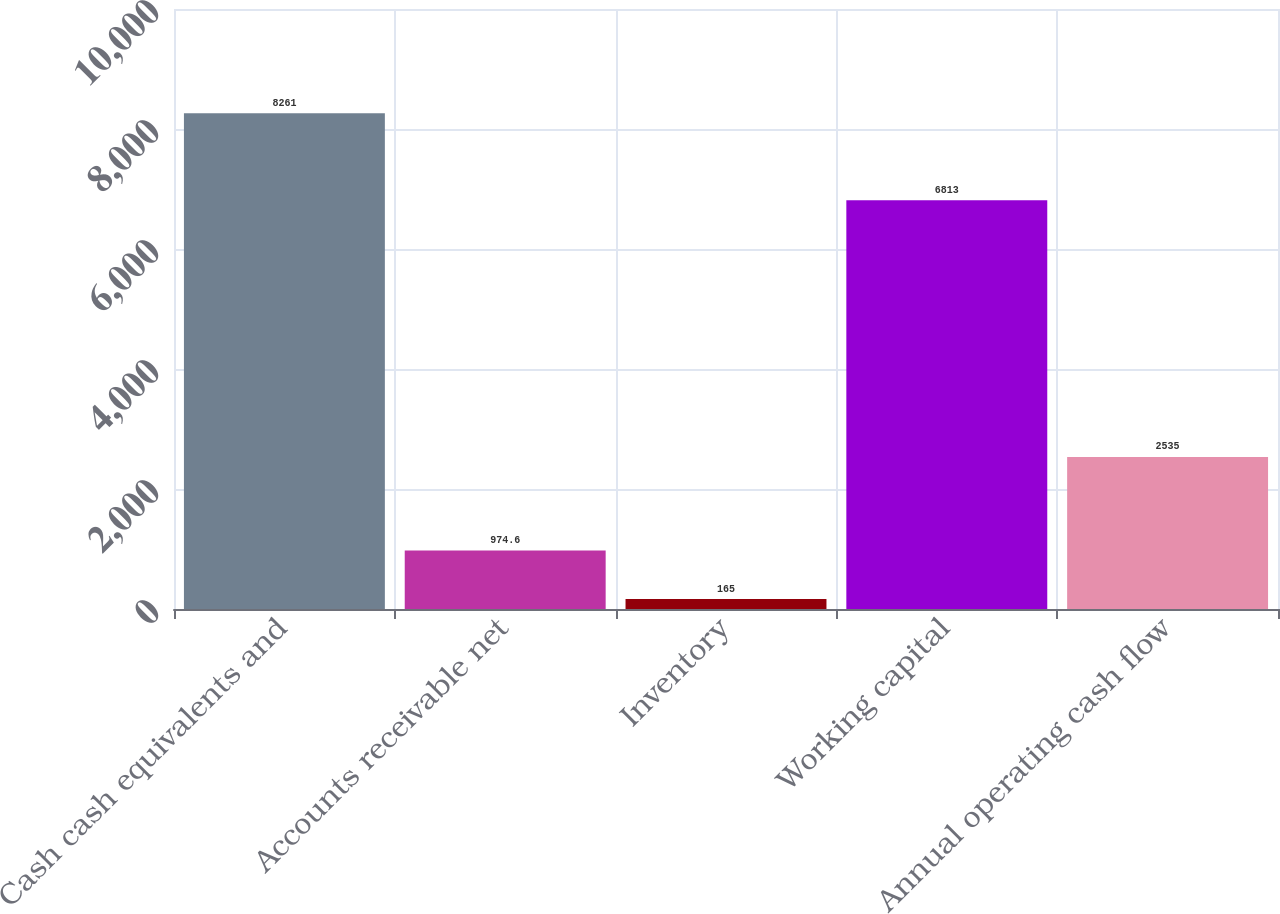Convert chart to OTSL. <chart><loc_0><loc_0><loc_500><loc_500><bar_chart><fcel>Cash cash equivalents and<fcel>Accounts receivable net<fcel>Inventory<fcel>Working capital<fcel>Annual operating cash flow<nl><fcel>8261<fcel>974.6<fcel>165<fcel>6813<fcel>2535<nl></chart> 